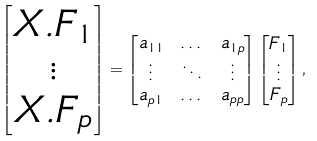<formula> <loc_0><loc_0><loc_500><loc_500>\begin{bmatrix} X . F _ { 1 } \\ \vdots \\ X . F _ { p } \end{bmatrix} & = \begin{bmatrix} a _ { 1 1 } & \dots & a _ { 1 p } \\ \vdots & \ddots & \vdots \\ a _ { p 1 } & \dots & a _ { p p } \end{bmatrix} \begin{bmatrix} F _ { 1 } \\ \vdots \\ F _ { p } \end{bmatrix} ,</formula> 